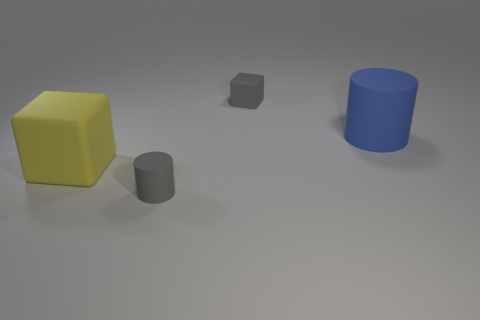Is the big rubber cube the same color as the tiny matte cylinder?
Make the answer very short. No. There is a rubber object that is both to the left of the big blue cylinder and right of the gray matte cylinder; what is its size?
Your response must be concise. Small. The small block that is the same material as the tiny gray cylinder is what color?
Your answer should be very brief. Gray. What number of other small cylinders have the same material as the blue cylinder?
Your answer should be very brief. 1. Is the number of large cylinders that are to the left of the gray rubber block the same as the number of yellow things behind the gray cylinder?
Make the answer very short. No. Is the shape of the yellow matte object the same as the small object that is to the right of the gray matte cylinder?
Your answer should be very brief. Yes. There is a tiny cylinder that is the same color as the tiny block; what material is it?
Offer a terse response. Rubber. Are there any other things that are the same shape as the yellow object?
Your answer should be very brief. Yes. Do the yellow object and the cylinder on the right side of the gray cylinder have the same material?
Offer a very short reply. Yes. There is a matte cube that is in front of the gray thing right of the small gray thing that is in front of the large blue rubber cylinder; what color is it?
Ensure brevity in your answer.  Yellow. 